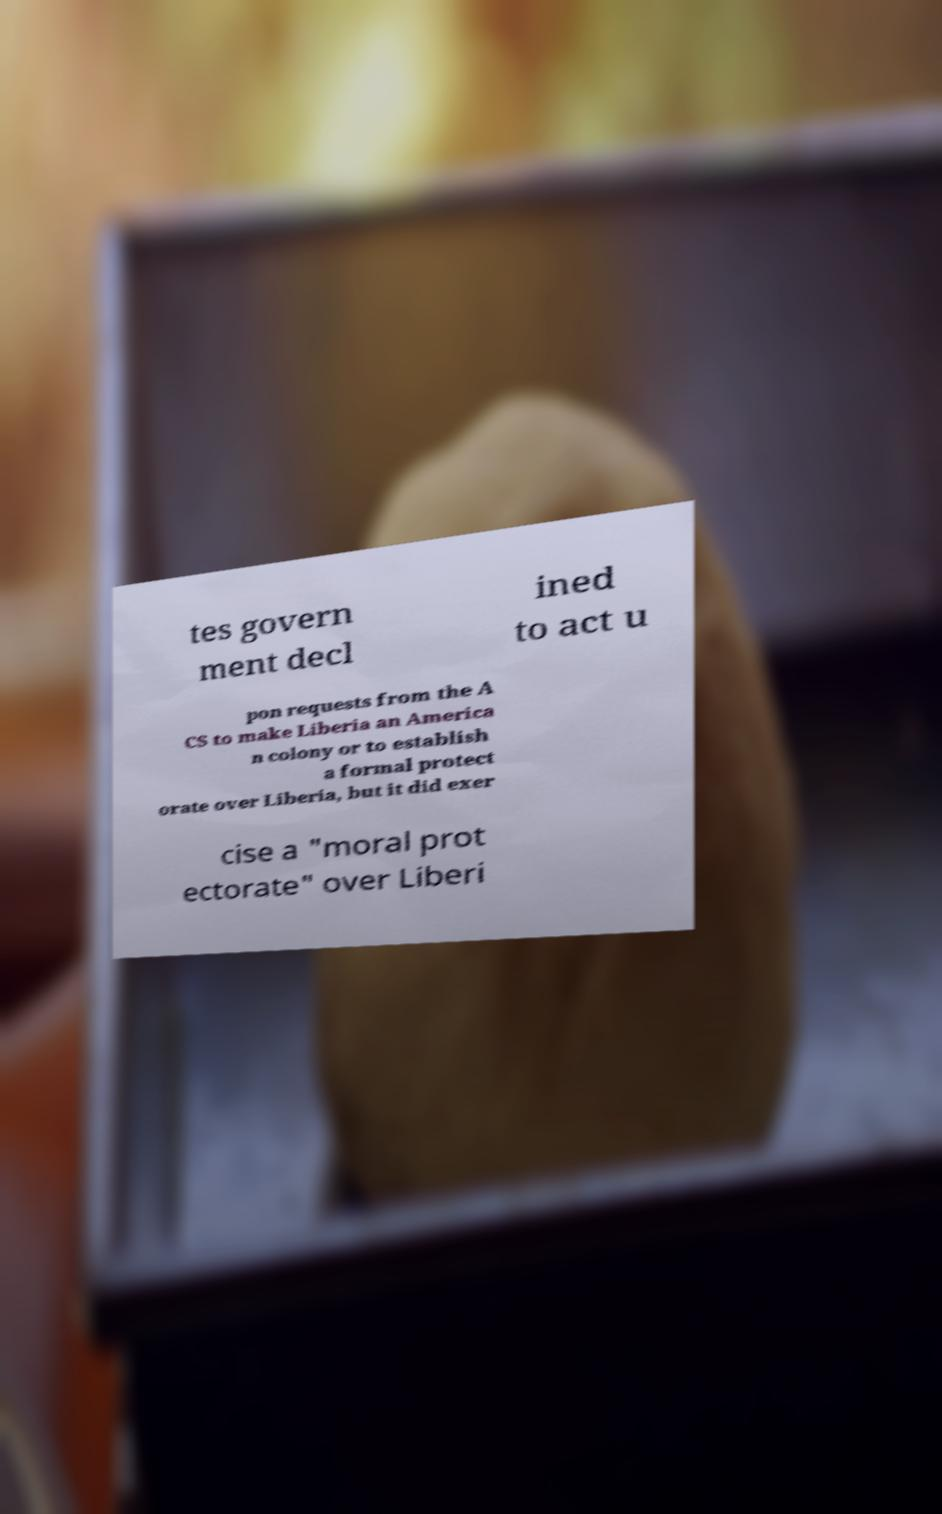Could you assist in decoding the text presented in this image and type it out clearly? tes govern ment decl ined to act u pon requests from the A CS to make Liberia an America n colony or to establish a formal protect orate over Liberia, but it did exer cise a "moral prot ectorate" over Liberi 